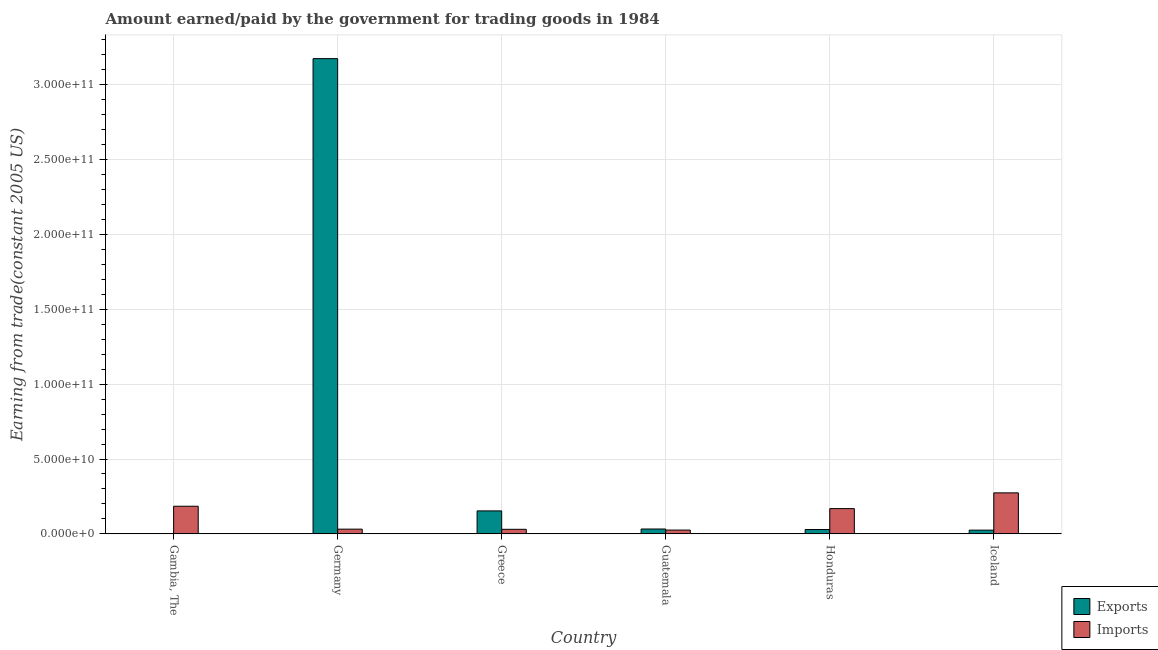Are the number of bars on each tick of the X-axis equal?
Your response must be concise. Yes. How many bars are there on the 5th tick from the left?
Make the answer very short. 2. What is the label of the 4th group of bars from the left?
Provide a short and direct response. Guatemala. What is the amount paid for imports in Honduras?
Offer a terse response. 1.69e+1. Across all countries, what is the maximum amount paid for imports?
Provide a short and direct response. 2.74e+1. Across all countries, what is the minimum amount earned from exports?
Offer a terse response. 2.03e+08. In which country was the amount earned from exports maximum?
Ensure brevity in your answer.  Germany. In which country was the amount earned from exports minimum?
Provide a short and direct response. Gambia, The. What is the total amount paid for imports in the graph?
Your response must be concise. 7.15e+1. What is the difference between the amount paid for imports in Greece and that in Iceland?
Give a very brief answer. -2.43e+1. What is the difference between the amount paid for imports in Honduras and the amount earned from exports in Greece?
Provide a succinct answer. 1.53e+09. What is the average amount earned from exports per country?
Your answer should be compact. 5.70e+1. What is the difference between the amount paid for imports and amount earned from exports in Honduras?
Give a very brief answer. 1.40e+1. In how many countries, is the amount paid for imports greater than 100000000000 US$?
Ensure brevity in your answer.  0. What is the ratio of the amount paid for imports in Guatemala to that in Iceland?
Provide a succinct answer. 0.09. Is the difference between the amount paid for imports in Gambia, The and Honduras greater than the difference between the amount earned from exports in Gambia, The and Honduras?
Ensure brevity in your answer.  Yes. What is the difference between the highest and the second highest amount paid for imports?
Offer a terse response. 8.94e+09. What is the difference between the highest and the lowest amount earned from exports?
Offer a terse response. 3.17e+11. In how many countries, is the amount paid for imports greater than the average amount paid for imports taken over all countries?
Keep it short and to the point. 3. Is the sum of the amount earned from exports in Gambia, The and Iceland greater than the maximum amount paid for imports across all countries?
Make the answer very short. No. What does the 1st bar from the left in Gambia, The represents?
Make the answer very short. Exports. What does the 1st bar from the right in Germany represents?
Your answer should be very brief. Imports. How many bars are there?
Give a very brief answer. 12. How many countries are there in the graph?
Your answer should be compact. 6. What is the difference between two consecutive major ticks on the Y-axis?
Your answer should be very brief. 5.00e+1. Are the values on the major ticks of Y-axis written in scientific E-notation?
Offer a terse response. Yes. Does the graph contain grids?
Ensure brevity in your answer.  Yes. Where does the legend appear in the graph?
Your answer should be compact. Bottom right. How are the legend labels stacked?
Give a very brief answer. Vertical. What is the title of the graph?
Provide a succinct answer. Amount earned/paid by the government for trading goods in 1984. What is the label or title of the X-axis?
Your answer should be compact. Country. What is the label or title of the Y-axis?
Make the answer very short. Earning from trade(constant 2005 US). What is the Earning from trade(constant 2005 US) in Exports in Gambia, The?
Make the answer very short. 2.03e+08. What is the Earning from trade(constant 2005 US) of Imports in Gambia, The?
Give a very brief answer. 1.85e+1. What is the Earning from trade(constant 2005 US) of Exports in Germany?
Offer a very short reply. 3.18e+11. What is the Earning from trade(constant 2005 US) of Imports in Germany?
Give a very brief answer. 3.15e+09. What is the Earning from trade(constant 2005 US) of Exports in Greece?
Make the answer very short. 1.53e+1. What is the Earning from trade(constant 2005 US) in Imports in Greece?
Offer a very short reply. 3.05e+09. What is the Earning from trade(constant 2005 US) of Exports in Guatemala?
Provide a short and direct response. 3.25e+09. What is the Earning from trade(constant 2005 US) in Imports in Guatemala?
Your answer should be compact. 2.53e+09. What is the Earning from trade(constant 2005 US) in Exports in Honduras?
Give a very brief answer. 2.90e+09. What is the Earning from trade(constant 2005 US) of Imports in Honduras?
Offer a terse response. 1.69e+1. What is the Earning from trade(constant 2005 US) in Exports in Iceland?
Offer a terse response. 2.49e+09. What is the Earning from trade(constant 2005 US) of Imports in Iceland?
Provide a short and direct response. 2.74e+1. Across all countries, what is the maximum Earning from trade(constant 2005 US) in Exports?
Provide a succinct answer. 3.18e+11. Across all countries, what is the maximum Earning from trade(constant 2005 US) in Imports?
Provide a succinct answer. 2.74e+1. Across all countries, what is the minimum Earning from trade(constant 2005 US) of Exports?
Make the answer very short. 2.03e+08. Across all countries, what is the minimum Earning from trade(constant 2005 US) of Imports?
Your response must be concise. 2.53e+09. What is the total Earning from trade(constant 2005 US) of Exports in the graph?
Provide a short and direct response. 3.42e+11. What is the total Earning from trade(constant 2005 US) in Imports in the graph?
Give a very brief answer. 7.15e+1. What is the difference between the Earning from trade(constant 2005 US) of Exports in Gambia, The and that in Germany?
Keep it short and to the point. -3.17e+11. What is the difference between the Earning from trade(constant 2005 US) in Imports in Gambia, The and that in Germany?
Offer a very short reply. 1.53e+1. What is the difference between the Earning from trade(constant 2005 US) of Exports in Gambia, The and that in Greece?
Provide a succinct answer. -1.51e+1. What is the difference between the Earning from trade(constant 2005 US) of Imports in Gambia, The and that in Greece?
Provide a short and direct response. 1.54e+1. What is the difference between the Earning from trade(constant 2005 US) of Exports in Gambia, The and that in Guatemala?
Provide a short and direct response. -3.04e+09. What is the difference between the Earning from trade(constant 2005 US) in Imports in Gambia, The and that in Guatemala?
Give a very brief answer. 1.59e+1. What is the difference between the Earning from trade(constant 2005 US) of Exports in Gambia, The and that in Honduras?
Provide a succinct answer. -2.69e+09. What is the difference between the Earning from trade(constant 2005 US) in Imports in Gambia, The and that in Honduras?
Give a very brief answer. 1.59e+09. What is the difference between the Earning from trade(constant 2005 US) of Exports in Gambia, The and that in Iceland?
Offer a very short reply. -2.28e+09. What is the difference between the Earning from trade(constant 2005 US) in Imports in Gambia, The and that in Iceland?
Your answer should be compact. -8.94e+09. What is the difference between the Earning from trade(constant 2005 US) of Exports in Germany and that in Greece?
Keep it short and to the point. 3.02e+11. What is the difference between the Earning from trade(constant 2005 US) in Imports in Germany and that in Greece?
Ensure brevity in your answer.  1.06e+08. What is the difference between the Earning from trade(constant 2005 US) in Exports in Germany and that in Guatemala?
Your answer should be very brief. 3.14e+11. What is the difference between the Earning from trade(constant 2005 US) in Imports in Germany and that in Guatemala?
Your answer should be compact. 6.23e+08. What is the difference between the Earning from trade(constant 2005 US) in Exports in Germany and that in Honduras?
Provide a succinct answer. 3.15e+11. What is the difference between the Earning from trade(constant 2005 US) in Imports in Germany and that in Honduras?
Ensure brevity in your answer.  -1.37e+1. What is the difference between the Earning from trade(constant 2005 US) in Exports in Germany and that in Iceland?
Your answer should be very brief. 3.15e+11. What is the difference between the Earning from trade(constant 2005 US) of Imports in Germany and that in Iceland?
Offer a terse response. -2.42e+1. What is the difference between the Earning from trade(constant 2005 US) in Exports in Greece and that in Guatemala?
Provide a short and direct response. 1.21e+1. What is the difference between the Earning from trade(constant 2005 US) in Imports in Greece and that in Guatemala?
Provide a succinct answer. 5.17e+08. What is the difference between the Earning from trade(constant 2005 US) of Exports in Greece and that in Honduras?
Provide a short and direct response. 1.24e+1. What is the difference between the Earning from trade(constant 2005 US) of Imports in Greece and that in Honduras?
Offer a very short reply. -1.38e+1. What is the difference between the Earning from trade(constant 2005 US) of Exports in Greece and that in Iceland?
Your answer should be compact. 1.29e+1. What is the difference between the Earning from trade(constant 2005 US) of Imports in Greece and that in Iceland?
Offer a very short reply. -2.43e+1. What is the difference between the Earning from trade(constant 2005 US) of Exports in Guatemala and that in Honduras?
Provide a short and direct response. 3.53e+08. What is the difference between the Earning from trade(constant 2005 US) of Imports in Guatemala and that in Honduras?
Your answer should be compact. -1.43e+1. What is the difference between the Earning from trade(constant 2005 US) of Exports in Guatemala and that in Iceland?
Your answer should be compact. 7.61e+08. What is the difference between the Earning from trade(constant 2005 US) of Imports in Guatemala and that in Iceland?
Your answer should be compact. -2.49e+1. What is the difference between the Earning from trade(constant 2005 US) of Exports in Honduras and that in Iceland?
Make the answer very short. 4.09e+08. What is the difference between the Earning from trade(constant 2005 US) in Imports in Honduras and that in Iceland?
Offer a very short reply. -1.05e+1. What is the difference between the Earning from trade(constant 2005 US) of Exports in Gambia, The and the Earning from trade(constant 2005 US) of Imports in Germany?
Offer a terse response. -2.95e+09. What is the difference between the Earning from trade(constant 2005 US) of Exports in Gambia, The and the Earning from trade(constant 2005 US) of Imports in Greece?
Your answer should be compact. -2.84e+09. What is the difference between the Earning from trade(constant 2005 US) of Exports in Gambia, The and the Earning from trade(constant 2005 US) of Imports in Guatemala?
Your answer should be compact. -2.33e+09. What is the difference between the Earning from trade(constant 2005 US) of Exports in Gambia, The and the Earning from trade(constant 2005 US) of Imports in Honduras?
Make the answer very short. -1.67e+1. What is the difference between the Earning from trade(constant 2005 US) of Exports in Gambia, The and the Earning from trade(constant 2005 US) of Imports in Iceland?
Provide a short and direct response. -2.72e+1. What is the difference between the Earning from trade(constant 2005 US) of Exports in Germany and the Earning from trade(constant 2005 US) of Imports in Greece?
Provide a short and direct response. 3.14e+11. What is the difference between the Earning from trade(constant 2005 US) of Exports in Germany and the Earning from trade(constant 2005 US) of Imports in Guatemala?
Your answer should be very brief. 3.15e+11. What is the difference between the Earning from trade(constant 2005 US) of Exports in Germany and the Earning from trade(constant 2005 US) of Imports in Honduras?
Provide a short and direct response. 3.01e+11. What is the difference between the Earning from trade(constant 2005 US) in Exports in Germany and the Earning from trade(constant 2005 US) in Imports in Iceland?
Give a very brief answer. 2.90e+11. What is the difference between the Earning from trade(constant 2005 US) in Exports in Greece and the Earning from trade(constant 2005 US) in Imports in Guatemala?
Offer a terse response. 1.28e+1. What is the difference between the Earning from trade(constant 2005 US) of Exports in Greece and the Earning from trade(constant 2005 US) of Imports in Honduras?
Your response must be concise. -1.53e+09. What is the difference between the Earning from trade(constant 2005 US) in Exports in Greece and the Earning from trade(constant 2005 US) in Imports in Iceland?
Make the answer very short. -1.21e+1. What is the difference between the Earning from trade(constant 2005 US) in Exports in Guatemala and the Earning from trade(constant 2005 US) in Imports in Honduras?
Provide a short and direct response. -1.36e+1. What is the difference between the Earning from trade(constant 2005 US) of Exports in Guatemala and the Earning from trade(constant 2005 US) of Imports in Iceland?
Your response must be concise. -2.41e+1. What is the difference between the Earning from trade(constant 2005 US) of Exports in Honduras and the Earning from trade(constant 2005 US) of Imports in Iceland?
Ensure brevity in your answer.  -2.45e+1. What is the average Earning from trade(constant 2005 US) of Exports per country?
Your answer should be very brief. 5.70e+1. What is the average Earning from trade(constant 2005 US) of Imports per country?
Ensure brevity in your answer.  1.19e+1. What is the difference between the Earning from trade(constant 2005 US) of Exports and Earning from trade(constant 2005 US) of Imports in Gambia, The?
Provide a succinct answer. -1.83e+1. What is the difference between the Earning from trade(constant 2005 US) of Exports and Earning from trade(constant 2005 US) of Imports in Germany?
Give a very brief answer. 3.14e+11. What is the difference between the Earning from trade(constant 2005 US) in Exports and Earning from trade(constant 2005 US) in Imports in Greece?
Give a very brief answer. 1.23e+1. What is the difference between the Earning from trade(constant 2005 US) of Exports and Earning from trade(constant 2005 US) of Imports in Guatemala?
Your response must be concise. 7.18e+08. What is the difference between the Earning from trade(constant 2005 US) of Exports and Earning from trade(constant 2005 US) of Imports in Honduras?
Provide a short and direct response. -1.40e+1. What is the difference between the Earning from trade(constant 2005 US) in Exports and Earning from trade(constant 2005 US) in Imports in Iceland?
Offer a terse response. -2.49e+1. What is the ratio of the Earning from trade(constant 2005 US) in Exports in Gambia, The to that in Germany?
Keep it short and to the point. 0. What is the ratio of the Earning from trade(constant 2005 US) in Imports in Gambia, The to that in Germany?
Provide a short and direct response. 5.85. What is the ratio of the Earning from trade(constant 2005 US) in Exports in Gambia, The to that in Greece?
Make the answer very short. 0.01. What is the ratio of the Earning from trade(constant 2005 US) in Imports in Gambia, The to that in Greece?
Ensure brevity in your answer.  6.06. What is the ratio of the Earning from trade(constant 2005 US) in Exports in Gambia, The to that in Guatemala?
Your response must be concise. 0.06. What is the ratio of the Earning from trade(constant 2005 US) of Imports in Gambia, The to that in Guatemala?
Give a very brief answer. 7.29. What is the ratio of the Earning from trade(constant 2005 US) in Exports in Gambia, The to that in Honduras?
Make the answer very short. 0.07. What is the ratio of the Earning from trade(constant 2005 US) of Imports in Gambia, The to that in Honduras?
Keep it short and to the point. 1.09. What is the ratio of the Earning from trade(constant 2005 US) of Exports in Gambia, The to that in Iceland?
Make the answer very short. 0.08. What is the ratio of the Earning from trade(constant 2005 US) of Imports in Gambia, The to that in Iceland?
Provide a succinct answer. 0.67. What is the ratio of the Earning from trade(constant 2005 US) in Exports in Germany to that in Greece?
Ensure brevity in your answer.  20.7. What is the ratio of the Earning from trade(constant 2005 US) of Imports in Germany to that in Greece?
Ensure brevity in your answer.  1.03. What is the ratio of the Earning from trade(constant 2005 US) of Exports in Germany to that in Guatemala?
Your response must be concise. 97.76. What is the ratio of the Earning from trade(constant 2005 US) of Imports in Germany to that in Guatemala?
Provide a short and direct response. 1.25. What is the ratio of the Earning from trade(constant 2005 US) in Exports in Germany to that in Honduras?
Ensure brevity in your answer.  109.68. What is the ratio of the Earning from trade(constant 2005 US) in Imports in Germany to that in Honduras?
Offer a very short reply. 0.19. What is the ratio of the Earning from trade(constant 2005 US) in Exports in Germany to that in Iceland?
Offer a terse response. 127.7. What is the ratio of the Earning from trade(constant 2005 US) in Imports in Germany to that in Iceland?
Keep it short and to the point. 0.12. What is the ratio of the Earning from trade(constant 2005 US) in Exports in Greece to that in Guatemala?
Offer a terse response. 4.72. What is the ratio of the Earning from trade(constant 2005 US) of Imports in Greece to that in Guatemala?
Your response must be concise. 1.2. What is the ratio of the Earning from trade(constant 2005 US) of Exports in Greece to that in Honduras?
Ensure brevity in your answer.  5.3. What is the ratio of the Earning from trade(constant 2005 US) in Imports in Greece to that in Honduras?
Ensure brevity in your answer.  0.18. What is the ratio of the Earning from trade(constant 2005 US) of Exports in Greece to that in Iceland?
Your answer should be compact. 6.17. What is the ratio of the Earning from trade(constant 2005 US) in Imports in Greece to that in Iceland?
Your answer should be compact. 0.11. What is the ratio of the Earning from trade(constant 2005 US) in Exports in Guatemala to that in Honduras?
Your answer should be very brief. 1.12. What is the ratio of the Earning from trade(constant 2005 US) in Exports in Guatemala to that in Iceland?
Your response must be concise. 1.31. What is the ratio of the Earning from trade(constant 2005 US) in Imports in Guatemala to that in Iceland?
Offer a very short reply. 0.09. What is the ratio of the Earning from trade(constant 2005 US) in Exports in Honduras to that in Iceland?
Give a very brief answer. 1.16. What is the ratio of the Earning from trade(constant 2005 US) of Imports in Honduras to that in Iceland?
Ensure brevity in your answer.  0.62. What is the difference between the highest and the second highest Earning from trade(constant 2005 US) in Exports?
Give a very brief answer. 3.02e+11. What is the difference between the highest and the second highest Earning from trade(constant 2005 US) in Imports?
Provide a short and direct response. 8.94e+09. What is the difference between the highest and the lowest Earning from trade(constant 2005 US) in Exports?
Offer a very short reply. 3.17e+11. What is the difference between the highest and the lowest Earning from trade(constant 2005 US) of Imports?
Offer a terse response. 2.49e+1. 